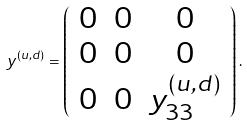Convert formula to latex. <formula><loc_0><loc_0><loc_500><loc_500>y ^ { ( u , d ) } = \left ( \begin{array} { c c c } 0 & 0 & 0 \\ 0 & 0 & 0 \\ 0 & 0 & y ^ { ( u , d ) } _ { 3 3 } \end{array} \right ) .</formula> 